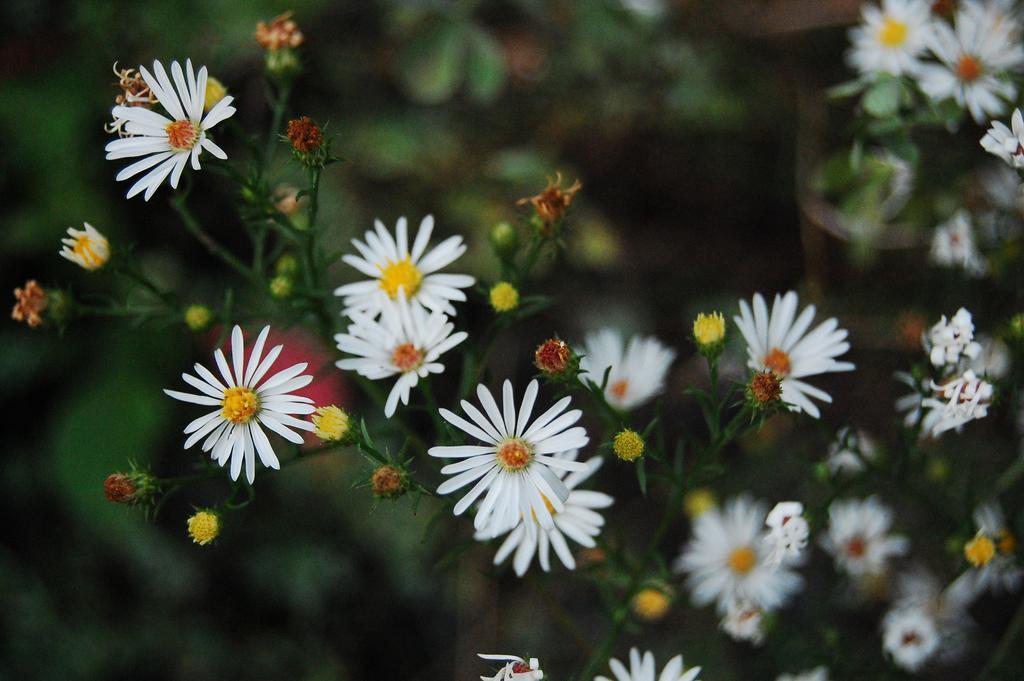Can you describe this image briefly? In this image in the foreground there are some flowers, and in the background there are plants. 